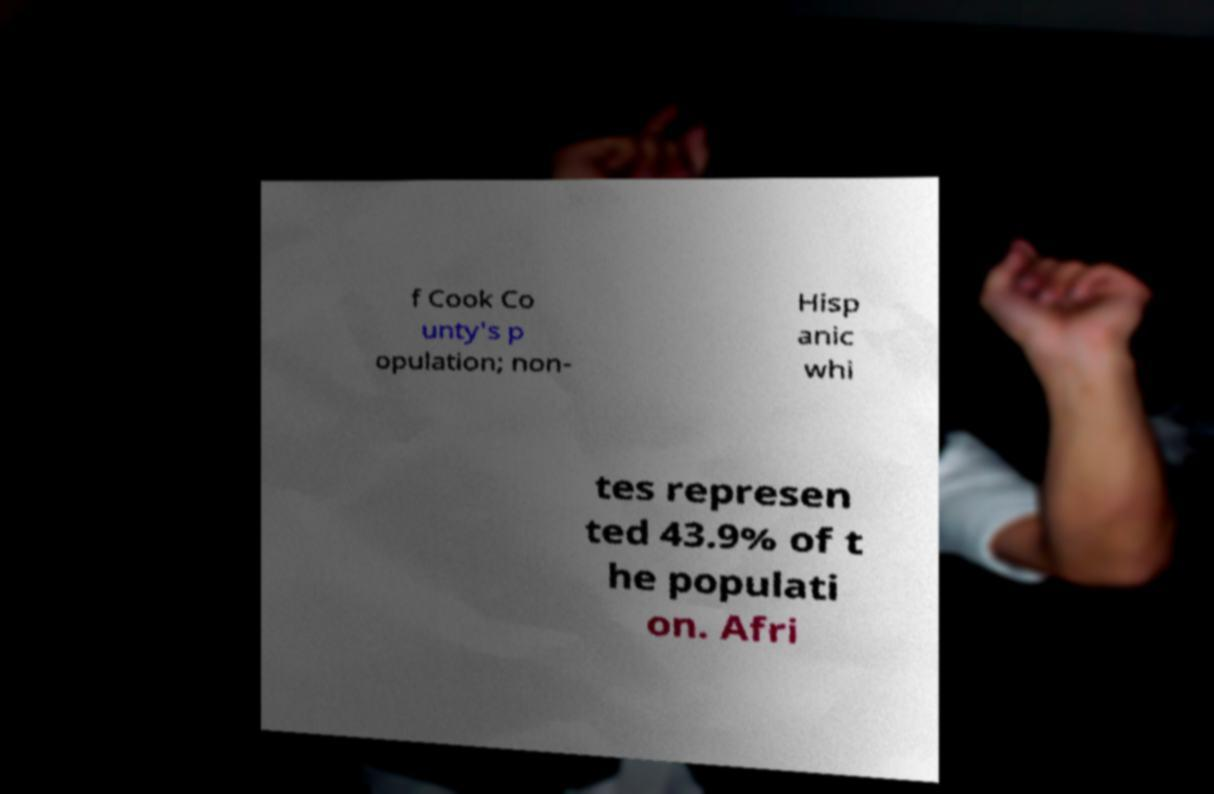Can you read and provide the text displayed in the image?This photo seems to have some interesting text. Can you extract and type it out for me? f Cook Co unty's p opulation; non- Hisp anic whi tes represen ted 43.9% of t he populati on. Afri 